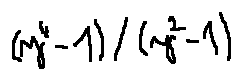Convert formula to latex. <formula><loc_0><loc_0><loc_500><loc_500>( y ^ { 4 } - 1 ) / ( y ^ { 2 } - 1 )</formula> 